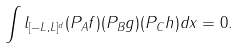Convert formula to latex. <formula><loc_0><loc_0><loc_500><loc_500>\int l _ { [ - L , L ] ^ { d } } ( P _ { A } f ) ( P _ { B } g ) ( P _ { C } h ) d x = 0 .</formula> 